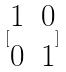<formula> <loc_0><loc_0><loc_500><loc_500>[ \begin{matrix} 1 & 0 \\ 0 & 1 \end{matrix} ]</formula> 